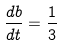<formula> <loc_0><loc_0><loc_500><loc_500>\frac { d b } { d t } = \frac { 1 } { 3 }</formula> 